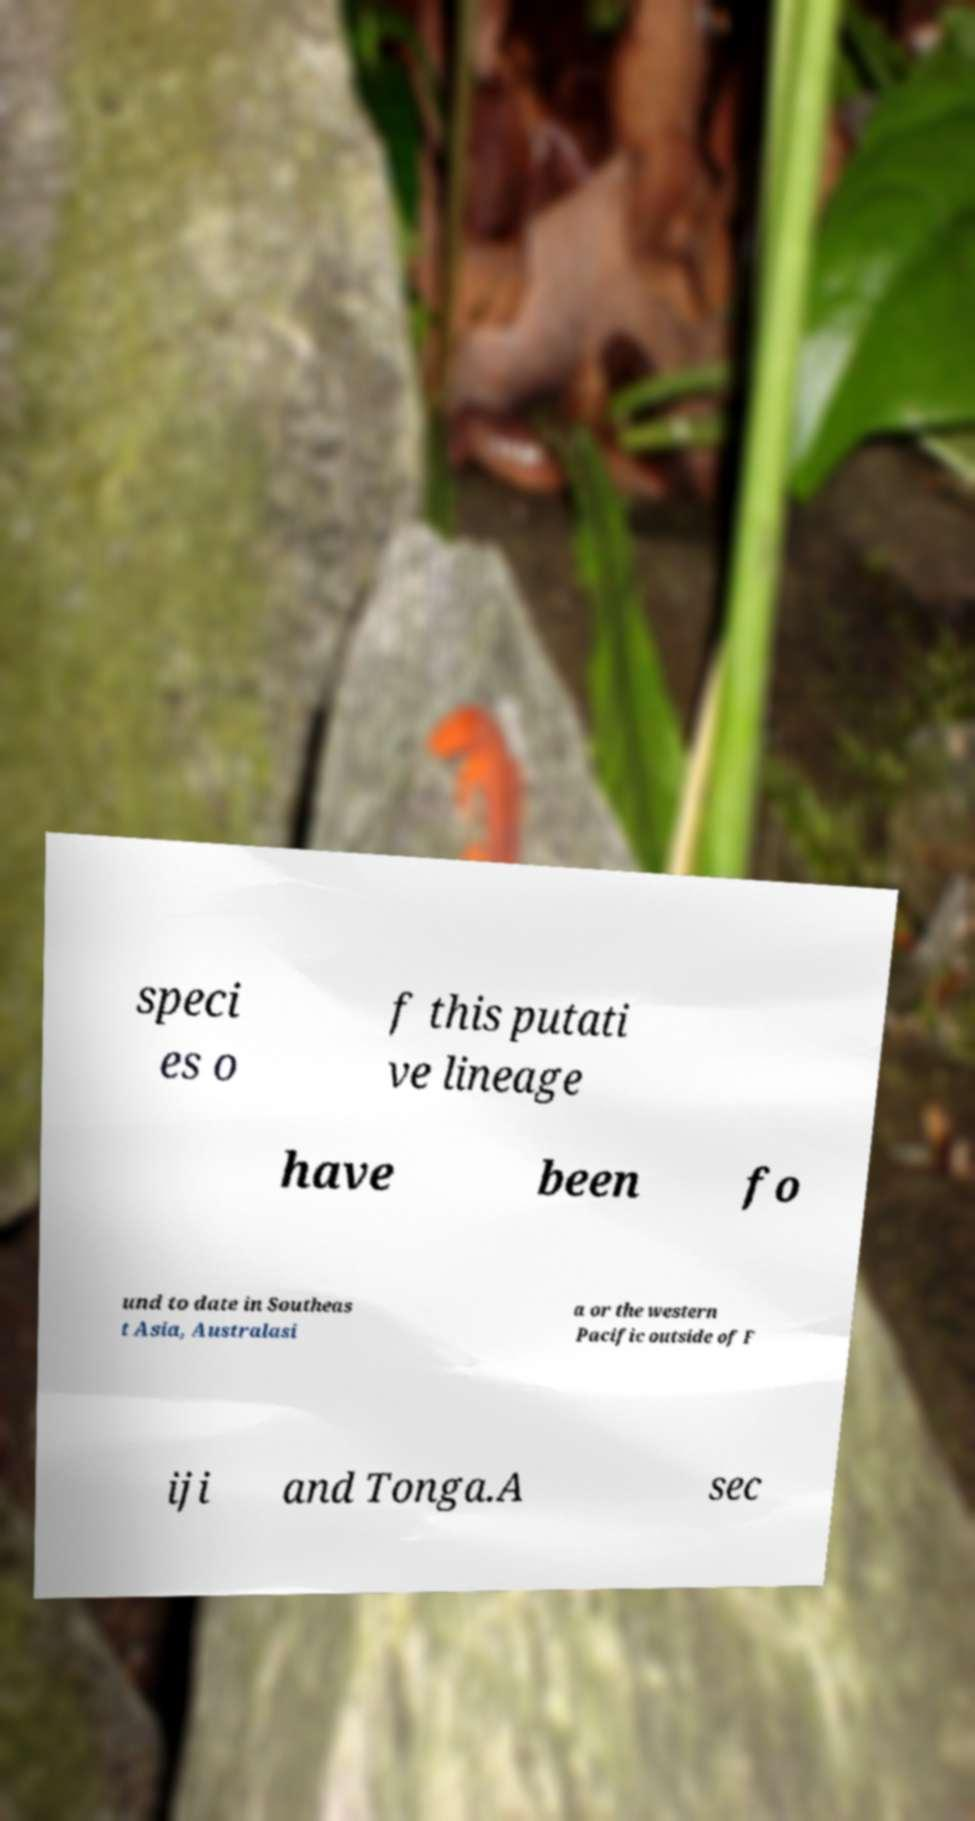I need the written content from this picture converted into text. Can you do that? speci es o f this putati ve lineage have been fo und to date in Southeas t Asia, Australasi a or the western Pacific outside of F iji and Tonga.A sec 